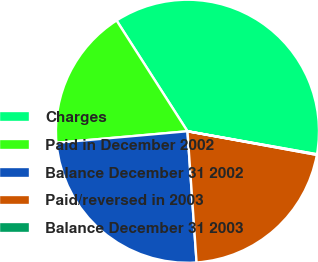<chart> <loc_0><loc_0><loc_500><loc_500><pie_chart><fcel>Charges<fcel>Paid in December 2002<fcel>Balance December 31 2002<fcel>Paid/reversed in 2003<fcel>Balance December 31 2003<nl><fcel>36.86%<fcel>17.34%<fcel>24.7%<fcel>21.02%<fcel>0.08%<nl></chart> 